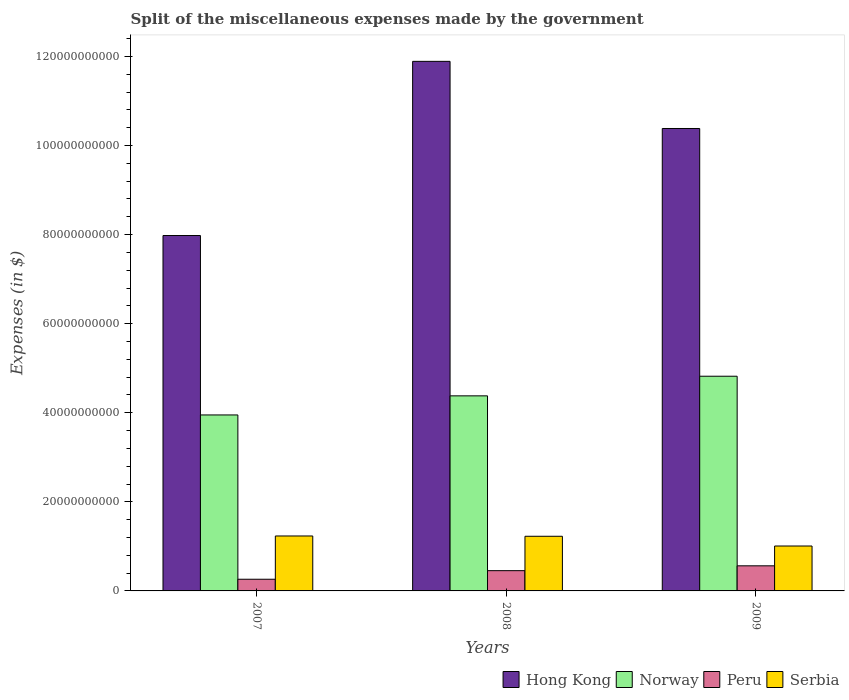How many different coloured bars are there?
Make the answer very short. 4. How many groups of bars are there?
Provide a short and direct response. 3. Are the number of bars per tick equal to the number of legend labels?
Your answer should be very brief. Yes. How many bars are there on the 1st tick from the left?
Your answer should be compact. 4. What is the label of the 2nd group of bars from the left?
Your response must be concise. 2008. What is the miscellaneous expenses made by the government in Norway in 2007?
Make the answer very short. 3.95e+1. Across all years, what is the maximum miscellaneous expenses made by the government in Norway?
Your answer should be compact. 4.82e+1. Across all years, what is the minimum miscellaneous expenses made by the government in Serbia?
Provide a succinct answer. 1.01e+1. In which year was the miscellaneous expenses made by the government in Peru maximum?
Ensure brevity in your answer.  2009. What is the total miscellaneous expenses made by the government in Peru in the graph?
Provide a short and direct response. 1.28e+1. What is the difference between the miscellaneous expenses made by the government in Hong Kong in 2007 and that in 2009?
Provide a succinct answer. -2.40e+1. What is the difference between the miscellaneous expenses made by the government in Hong Kong in 2008 and the miscellaneous expenses made by the government in Serbia in 2009?
Offer a very short reply. 1.09e+11. What is the average miscellaneous expenses made by the government in Peru per year?
Give a very brief answer. 4.27e+09. In the year 2008, what is the difference between the miscellaneous expenses made by the government in Serbia and miscellaneous expenses made by the government in Peru?
Give a very brief answer. 7.72e+09. What is the ratio of the miscellaneous expenses made by the government in Hong Kong in 2007 to that in 2008?
Make the answer very short. 0.67. Is the difference between the miscellaneous expenses made by the government in Serbia in 2008 and 2009 greater than the difference between the miscellaneous expenses made by the government in Peru in 2008 and 2009?
Keep it short and to the point. Yes. What is the difference between the highest and the second highest miscellaneous expenses made by the government in Peru?
Your answer should be very brief. 1.09e+09. What is the difference between the highest and the lowest miscellaneous expenses made by the government in Hong Kong?
Your answer should be compact. 3.91e+1. Is the sum of the miscellaneous expenses made by the government in Norway in 2007 and 2008 greater than the maximum miscellaneous expenses made by the government in Serbia across all years?
Provide a succinct answer. Yes. Is it the case that in every year, the sum of the miscellaneous expenses made by the government in Peru and miscellaneous expenses made by the government in Norway is greater than the sum of miscellaneous expenses made by the government in Serbia and miscellaneous expenses made by the government in Hong Kong?
Your answer should be very brief. Yes. What does the 1st bar from the right in 2009 represents?
Provide a succinct answer. Serbia. Are all the bars in the graph horizontal?
Provide a succinct answer. No. How many years are there in the graph?
Offer a terse response. 3. Are the values on the major ticks of Y-axis written in scientific E-notation?
Your answer should be very brief. No. Does the graph contain grids?
Offer a very short reply. No. Where does the legend appear in the graph?
Your answer should be compact. Bottom right. What is the title of the graph?
Your answer should be compact. Split of the miscellaneous expenses made by the government. Does "Czech Republic" appear as one of the legend labels in the graph?
Make the answer very short. No. What is the label or title of the X-axis?
Ensure brevity in your answer.  Years. What is the label or title of the Y-axis?
Give a very brief answer. Expenses (in $). What is the Expenses (in $) of Hong Kong in 2007?
Provide a short and direct response. 7.98e+1. What is the Expenses (in $) of Norway in 2007?
Offer a very short reply. 3.95e+1. What is the Expenses (in $) of Peru in 2007?
Keep it short and to the point. 2.62e+09. What is the Expenses (in $) in Serbia in 2007?
Ensure brevity in your answer.  1.23e+1. What is the Expenses (in $) of Hong Kong in 2008?
Your answer should be very brief. 1.19e+11. What is the Expenses (in $) in Norway in 2008?
Give a very brief answer. 4.38e+1. What is the Expenses (in $) of Peru in 2008?
Give a very brief answer. 4.55e+09. What is the Expenses (in $) of Serbia in 2008?
Your answer should be very brief. 1.23e+1. What is the Expenses (in $) of Hong Kong in 2009?
Provide a succinct answer. 1.04e+11. What is the Expenses (in $) in Norway in 2009?
Provide a short and direct response. 4.82e+1. What is the Expenses (in $) in Peru in 2009?
Ensure brevity in your answer.  5.63e+09. What is the Expenses (in $) of Serbia in 2009?
Your answer should be compact. 1.01e+1. Across all years, what is the maximum Expenses (in $) of Hong Kong?
Make the answer very short. 1.19e+11. Across all years, what is the maximum Expenses (in $) in Norway?
Provide a short and direct response. 4.82e+1. Across all years, what is the maximum Expenses (in $) in Peru?
Ensure brevity in your answer.  5.63e+09. Across all years, what is the maximum Expenses (in $) in Serbia?
Give a very brief answer. 1.23e+1. Across all years, what is the minimum Expenses (in $) in Hong Kong?
Provide a short and direct response. 7.98e+1. Across all years, what is the minimum Expenses (in $) in Norway?
Give a very brief answer. 3.95e+1. Across all years, what is the minimum Expenses (in $) of Peru?
Offer a terse response. 2.62e+09. Across all years, what is the minimum Expenses (in $) in Serbia?
Offer a very short reply. 1.01e+1. What is the total Expenses (in $) of Hong Kong in the graph?
Make the answer very short. 3.02e+11. What is the total Expenses (in $) in Norway in the graph?
Offer a terse response. 1.31e+11. What is the total Expenses (in $) of Peru in the graph?
Ensure brevity in your answer.  1.28e+1. What is the total Expenses (in $) of Serbia in the graph?
Make the answer very short. 3.47e+1. What is the difference between the Expenses (in $) in Hong Kong in 2007 and that in 2008?
Keep it short and to the point. -3.91e+1. What is the difference between the Expenses (in $) in Norway in 2007 and that in 2008?
Keep it short and to the point. -4.29e+09. What is the difference between the Expenses (in $) in Peru in 2007 and that in 2008?
Keep it short and to the point. -1.93e+09. What is the difference between the Expenses (in $) of Serbia in 2007 and that in 2008?
Your response must be concise. 6.43e+07. What is the difference between the Expenses (in $) of Hong Kong in 2007 and that in 2009?
Offer a terse response. -2.40e+1. What is the difference between the Expenses (in $) in Norway in 2007 and that in 2009?
Offer a terse response. -8.69e+09. What is the difference between the Expenses (in $) in Peru in 2007 and that in 2009?
Your answer should be very brief. -3.01e+09. What is the difference between the Expenses (in $) in Serbia in 2007 and that in 2009?
Your answer should be very brief. 2.25e+09. What is the difference between the Expenses (in $) of Hong Kong in 2008 and that in 2009?
Offer a terse response. 1.51e+1. What is the difference between the Expenses (in $) in Norway in 2008 and that in 2009?
Your response must be concise. -4.40e+09. What is the difference between the Expenses (in $) in Peru in 2008 and that in 2009?
Keep it short and to the point. -1.09e+09. What is the difference between the Expenses (in $) of Serbia in 2008 and that in 2009?
Offer a terse response. 2.19e+09. What is the difference between the Expenses (in $) in Hong Kong in 2007 and the Expenses (in $) in Norway in 2008?
Give a very brief answer. 3.60e+1. What is the difference between the Expenses (in $) in Hong Kong in 2007 and the Expenses (in $) in Peru in 2008?
Keep it short and to the point. 7.52e+1. What is the difference between the Expenses (in $) in Hong Kong in 2007 and the Expenses (in $) in Serbia in 2008?
Your answer should be very brief. 6.75e+1. What is the difference between the Expenses (in $) in Norway in 2007 and the Expenses (in $) in Peru in 2008?
Offer a terse response. 3.50e+1. What is the difference between the Expenses (in $) of Norway in 2007 and the Expenses (in $) of Serbia in 2008?
Your response must be concise. 2.72e+1. What is the difference between the Expenses (in $) in Peru in 2007 and the Expenses (in $) in Serbia in 2008?
Provide a short and direct response. -9.65e+09. What is the difference between the Expenses (in $) of Hong Kong in 2007 and the Expenses (in $) of Norway in 2009?
Keep it short and to the point. 3.16e+1. What is the difference between the Expenses (in $) of Hong Kong in 2007 and the Expenses (in $) of Peru in 2009?
Your response must be concise. 7.41e+1. What is the difference between the Expenses (in $) in Hong Kong in 2007 and the Expenses (in $) in Serbia in 2009?
Ensure brevity in your answer.  6.97e+1. What is the difference between the Expenses (in $) in Norway in 2007 and the Expenses (in $) in Peru in 2009?
Ensure brevity in your answer.  3.39e+1. What is the difference between the Expenses (in $) in Norway in 2007 and the Expenses (in $) in Serbia in 2009?
Give a very brief answer. 2.94e+1. What is the difference between the Expenses (in $) in Peru in 2007 and the Expenses (in $) in Serbia in 2009?
Your answer should be compact. -7.46e+09. What is the difference between the Expenses (in $) of Hong Kong in 2008 and the Expenses (in $) of Norway in 2009?
Your response must be concise. 7.07e+1. What is the difference between the Expenses (in $) in Hong Kong in 2008 and the Expenses (in $) in Peru in 2009?
Offer a very short reply. 1.13e+11. What is the difference between the Expenses (in $) in Hong Kong in 2008 and the Expenses (in $) in Serbia in 2009?
Offer a very short reply. 1.09e+11. What is the difference between the Expenses (in $) in Norway in 2008 and the Expenses (in $) in Peru in 2009?
Offer a very short reply. 3.82e+1. What is the difference between the Expenses (in $) of Norway in 2008 and the Expenses (in $) of Serbia in 2009?
Provide a short and direct response. 3.37e+1. What is the difference between the Expenses (in $) of Peru in 2008 and the Expenses (in $) of Serbia in 2009?
Your answer should be very brief. -5.53e+09. What is the average Expenses (in $) of Hong Kong per year?
Provide a succinct answer. 1.01e+11. What is the average Expenses (in $) of Norway per year?
Provide a short and direct response. 4.38e+1. What is the average Expenses (in $) in Peru per year?
Your response must be concise. 4.27e+09. What is the average Expenses (in $) of Serbia per year?
Keep it short and to the point. 1.16e+1. In the year 2007, what is the difference between the Expenses (in $) of Hong Kong and Expenses (in $) of Norway?
Your response must be concise. 4.03e+1. In the year 2007, what is the difference between the Expenses (in $) of Hong Kong and Expenses (in $) of Peru?
Make the answer very short. 7.72e+1. In the year 2007, what is the difference between the Expenses (in $) of Hong Kong and Expenses (in $) of Serbia?
Give a very brief answer. 6.75e+1. In the year 2007, what is the difference between the Expenses (in $) of Norway and Expenses (in $) of Peru?
Offer a very short reply. 3.69e+1. In the year 2007, what is the difference between the Expenses (in $) of Norway and Expenses (in $) of Serbia?
Your answer should be very brief. 2.72e+1. In the year 2007, what is the difference between the Expenses (in $) in Peru and Expenses (in $) in Serbia?
Ensure brevity in your answer.  -9.71e+09. In the year 2008, what is the difference between the Expenses (in $) in Hong Kong and Expenses (in $) in Norway?
Offer a very short reply. 7.51e+1. In the year 2008, what is the difference between the Expenses (in $) in Hong Kong and Expenses (in $) in Peru?
Offer a very short reply. 1.14e+11. In the year 2008, what is the difference between the Expenses (in $) of Hong Kong and Expenses (in $) of Serbia?
Make the answer very short. 1.07e+11. In the year 2008, what is the difference between the Expenses (in $) in Norway and Expenses (in $) in Peru?
Give a very brief answer. 3.92e+1. In the year 2008, what is the difference between the Expenses (in $) in Norway and Expenses (in $) in Serbia?
Offer a very short reply. 3.15e+1. In the year 2008, what is the difference between the Expenses (in $) in Peru and Expenses (in $) in Serbia?
Provide a succinct answer. -7.72e+09. In the year 2009, what is the difference between the Expenses (in $) of Hong Kong and Expenses (in $) of Norway?
Keep it short and to the point. 5.56e+1. In the year 2009, what is the difference between the Expenses (in $) in Hong Kong and Expenses (in $) in Peru?
Your answer should be very brief. 9.82e+1. In the year 2009, what is the difference between the Expenses (in $) of Hong Kong and Expenses (in $) of Serbia?
Your answer should be very brief. 9.37e+1. In the year 2009, what is the difference between the Expenses (in $) in Norway and Expenses (in $) in Peru?
Your response must be concise. 4.26e+1. In the year 2009, what is the difference between the Expenses (in $) in Norway and Expenses (in $) in Serbia?
Offer a terse response. 3.81e+1. In the year 2009, what is the difference between the Expenses (in $) of Peru and Expenses (in $) of Serbia?
Give a very brief answer. -4.45e+09. What is the ratio of the Expenses (in $) of Hong Kong in 2007 to that in 2008?
Ensure brevity in your answer.  0.67. What is the ratio of the Expenses (in $) in Norway in 2007 to that in 2008?
Ensure brevity in your answer.  0.9. What is the ratio of the Expenses (in $) in Peru in 2007 to that in 2008?
Keep it short and to the point. 0.58. What is the ratio of the Expenses (in $) of Hong Kong in 2007 to that in 2009?
Ensure brevity in your answer.  0.77. What is the ratio of the Expenses (in $) in Norway in 2007 to that in 2009?
Your answer should be very brief. 0.82. What is the ratio of the Expenses (in $) in Peru in 2007 to that in 2009?
Offer a terse response. 0.47. What is the ratio of the Expenses (in $) in Serbia in 2007 to that in 2009?
Give a very brief answer. 1.22. What is the ratio of the Expenses (in $) in Hong Kong in 2008 to that in 2009?
Provide a succinct answer. 1.15. What is the ratio of the Expenses (in $) in Norway in 2008 to that in 2009?
Ensure brevity in your answer.  0.91. What is the ratio of the Expenses (in $) of Peru in 2008 to that in 2009?
Offer a terse response. 0.81. What is the ratio of the Expenses (in $) in Serbia in 2008 to that in 2009?
Your answer should be very brief. 1.22. What is the difference between the highest and the second highest Expenses (in $) in Hong Kong?
Make the answer very short. 1.51e+1. What is the difference between the highest and the second highest Expenses (in $) of Norway?
Your response must be concise. 4.40e+09. What is the difference between the highest and the second highest Expenses (in $) in Peru?
Give a very brief answer. 1.09e+09. What is the difference between the highest and the second highest Expenses (in $) in Serbia?
Your answer should be compact. 6.43e+07. What is the difference between the highest and the lowest Expenses (in $) of Hong Kong?
Provide a short and direct response. 3.91e+1. What is the difference between the highest and the lowest Expenses (in $) of Norway?
Provide a succinct answer. 8.69e+09. What is the difference between the highest and the lowest Expenses (in $) in Peru?
Your answer should be very brief. 3.01e+09. What is the difference between the highest and the lowest Expenses (in $) in Serbia?
Give a very brief answer. 2.25e+09. 